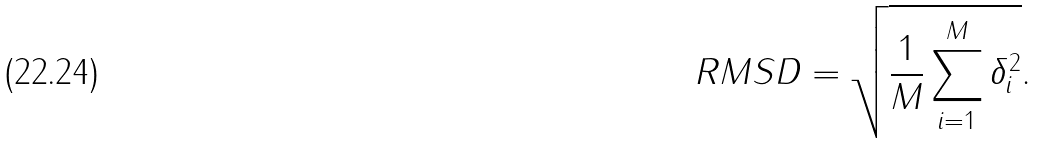Convert formula to latex. <formula><loc_0><loc_0><loc_500><loc_500>R M S D = \sqrt { \frac { 1 } { M } \sum _ { i = 1 } ^ { M } \delta _ { i } ^ { 2 } } .</formula> 